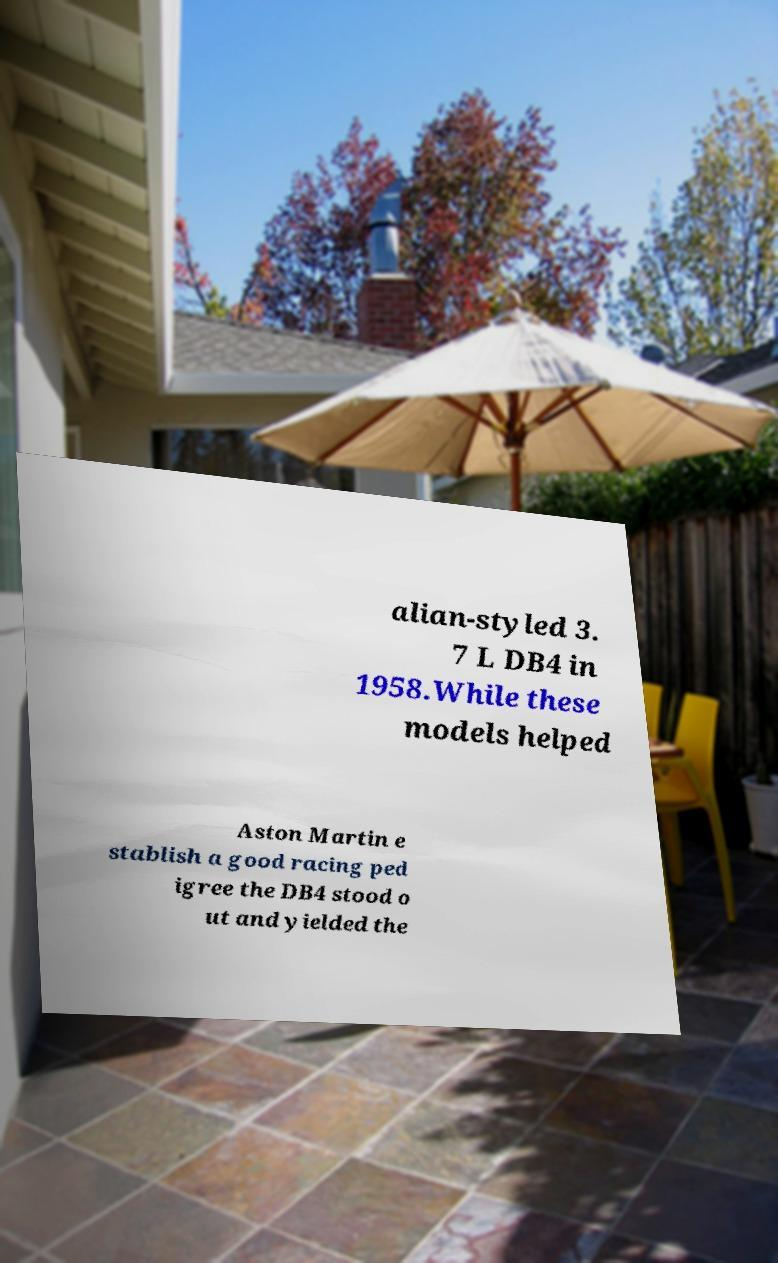There's text embedded in this image that I need extracted. Can you transcribe it verbatim? alian-styled 3. 7 L DB4 in 1958.While these models helped Aston Martin e stablish a good racing ped igree the DB4 stood o ut and yielded the 